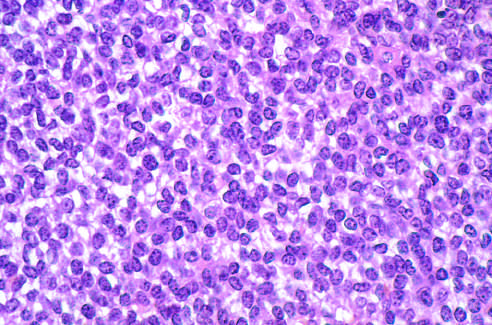s a liver composed of sheets of small round cells with small amounts of clear cytoplasm?
Answer the question using a single word or phrase. No 